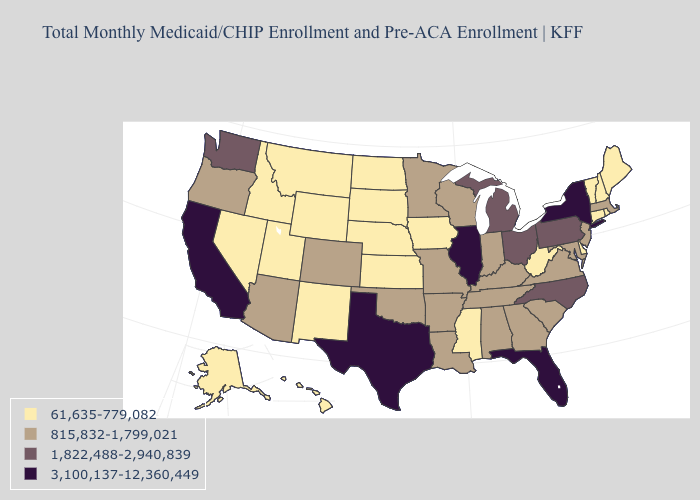What is the highest value in states that border Maine?
Keep it brief. 61,635-779,082. What is the value of Indiana?
Keep it brief. 815,832-1,799,021. Does Kansas have the same value as Virginia?
Answer briefly. No. How many symbols are there in the legend?
Quick response, please. 4. Which states hav the highest value in the MidWest?
Short answer required. Illinois. What is the value of Oklahoma?
Quick response, please. 815,832-1,799,021. Does Wyoming have the highest value in the West?
Write a very short answer. No. Name the states that have a value in the range 1,822,488-2,940,839?
Write a very short answer. Michigan, North Carolina, Ohio, Pennsylvania, Washington. Does Tennessee have a higher value than Texas?
Quick response, please. No. Among the states that border Oregon , which have the lowest value?
Quick response, please. Idaho, Nevada. Does the first symbol in the legend represent the smallest category?
Write a very short answer. Yes. Does Georgia have a lower value than New Hampshire?
Quick response, please. No. Does Indiana have a lower value than Pennsylvania?
Keep it brief. Yes. What is the value of Montana?
Keep it brief. 61,635-779,082. Among the states that border New Jersey , does Delaware have the highest value?
Keep it brief. No. 